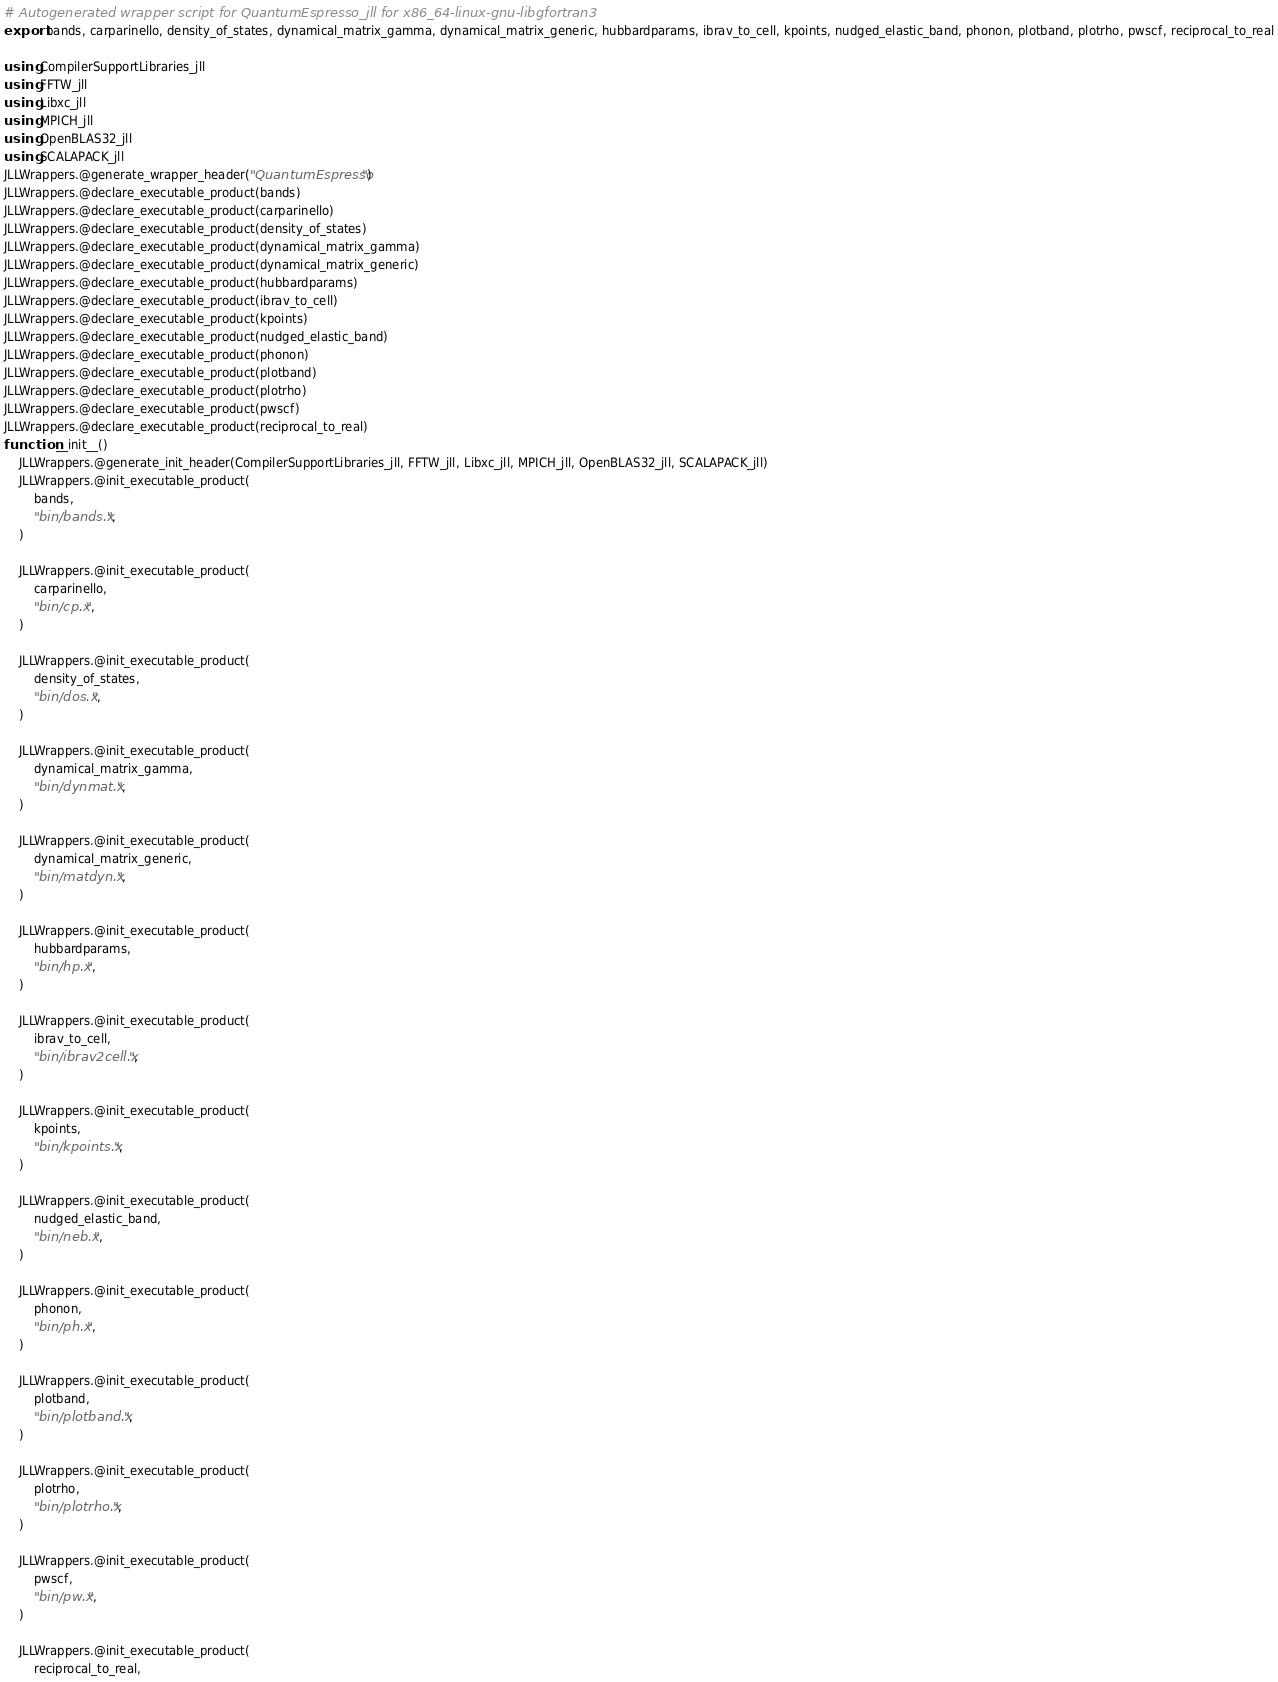<code> <loc_0><loc_0><loc_500><loc_500><_Julia_># Autogenerated wrapper script for QuantumEspresso_jll for x86_64-linux-gnu-libgfortran3
export bands, carparinello, density_of_states, dynamical_matrix_gamma, dynamical_matrix_generic, hubbardparams, ibrav_to_cell, kpoints, nudged_elastic_band, phonon, plotband, plotrho, pwscf, reciprocal_to_real

using CompilerSupportLibraries_jll
using FFTW_jll
using Libxc_jll
using MPICH_jll
using OpenBLAS32_jll
using SCALAPACK_jll
JLLWrappers.@generate_wrapper_header("QuantumEspresso")
JLLWrappers.@declare_executable_product(bands)
JLLWrappers.@declare_executable_product(carparinello)
JLLWrappers.@declare_executable_product(density_of_states)
JLLWrappers.@declare_executable_product(dynamical_matrix_gamma)
JLLWrappers.@declare_executable_product(dynamical_matrix_generic)
JLLWrappers.@declare_executable_product(hubbardparams)
JLLWrappers.@declare_executable_product(ibrav_to_cell)
JLLWrappers.@declare_executable_product(kpoints)
JLLWrappers.@declare_executable_product(nudged_elastic_band)
JLLWrappers.@declare_executable_product(phonon)
JLLWrappers.@declare_executable_product(plotband)
JLLWrappers.@declare_executable_product(plotrho)
JLLWrappers.@declare_executable_product(pwscf)
JLLWrappers.@declare_executable_product(reciprocal_to_real)
function __init__()
    JLLWrappers.@generate_init_header(CompilerSupportLibraries_jll, FFTW_jll, Libxc_jll, MPICH_jll, OpenBLAS32_jll, SCALAPACK_jll)
    JLLWrappers.@init_executable_product(
        bands,
        "bin/bands.x",
    )

    JLLWrappers.@init_executable_product(
        carparinello,
        "bin/cp.x",
    )

    JLLWrappers.@init_executable_product(
        density_of_states,
        "bin/dos.x",
    )

    JLLWrappers.@init_executable_product(
        dynamical_matrix_gamma,
        "bin/dynmat.x",
    )

    JLLWrappers.@init_executable_product(
        dynamical_matrix_generic,
        "bin/matdyn.x",
    )

    JLLWrappers.@init_executable_product(
        hubbardparams,
        "bin/hp.x",
    )

    JLLWrappers.@init_executable_product(
        ibrav_to_cell,
        "bin/ibrav2cell.x",
    )

    JLLWrappers.@init_executable_product(
        kpoints,
        "bin/kpoints.x",
    )

    JLLWrappers.@init_executable_product(
        nudged_elastic_band,
        "bin/neb.x",
    )

    JLLWrappers.@init_executable_product(
        phonon,
        "bin/ph.x",
    )

    JLLWrappers.@init_executable_product(
        plotband,
        "bin/plotband.x",
    )

    JLLWrappers.@init_executable_product(
        plotrho,
        "bin/plotrho.x",
    )

    JLLWrappers.@init_executable_product(
        pwscf,
        "bin/pw.x",
    )

    JLLWrappers.@init_executable_product(
        reciprocal_to_real,</code> 